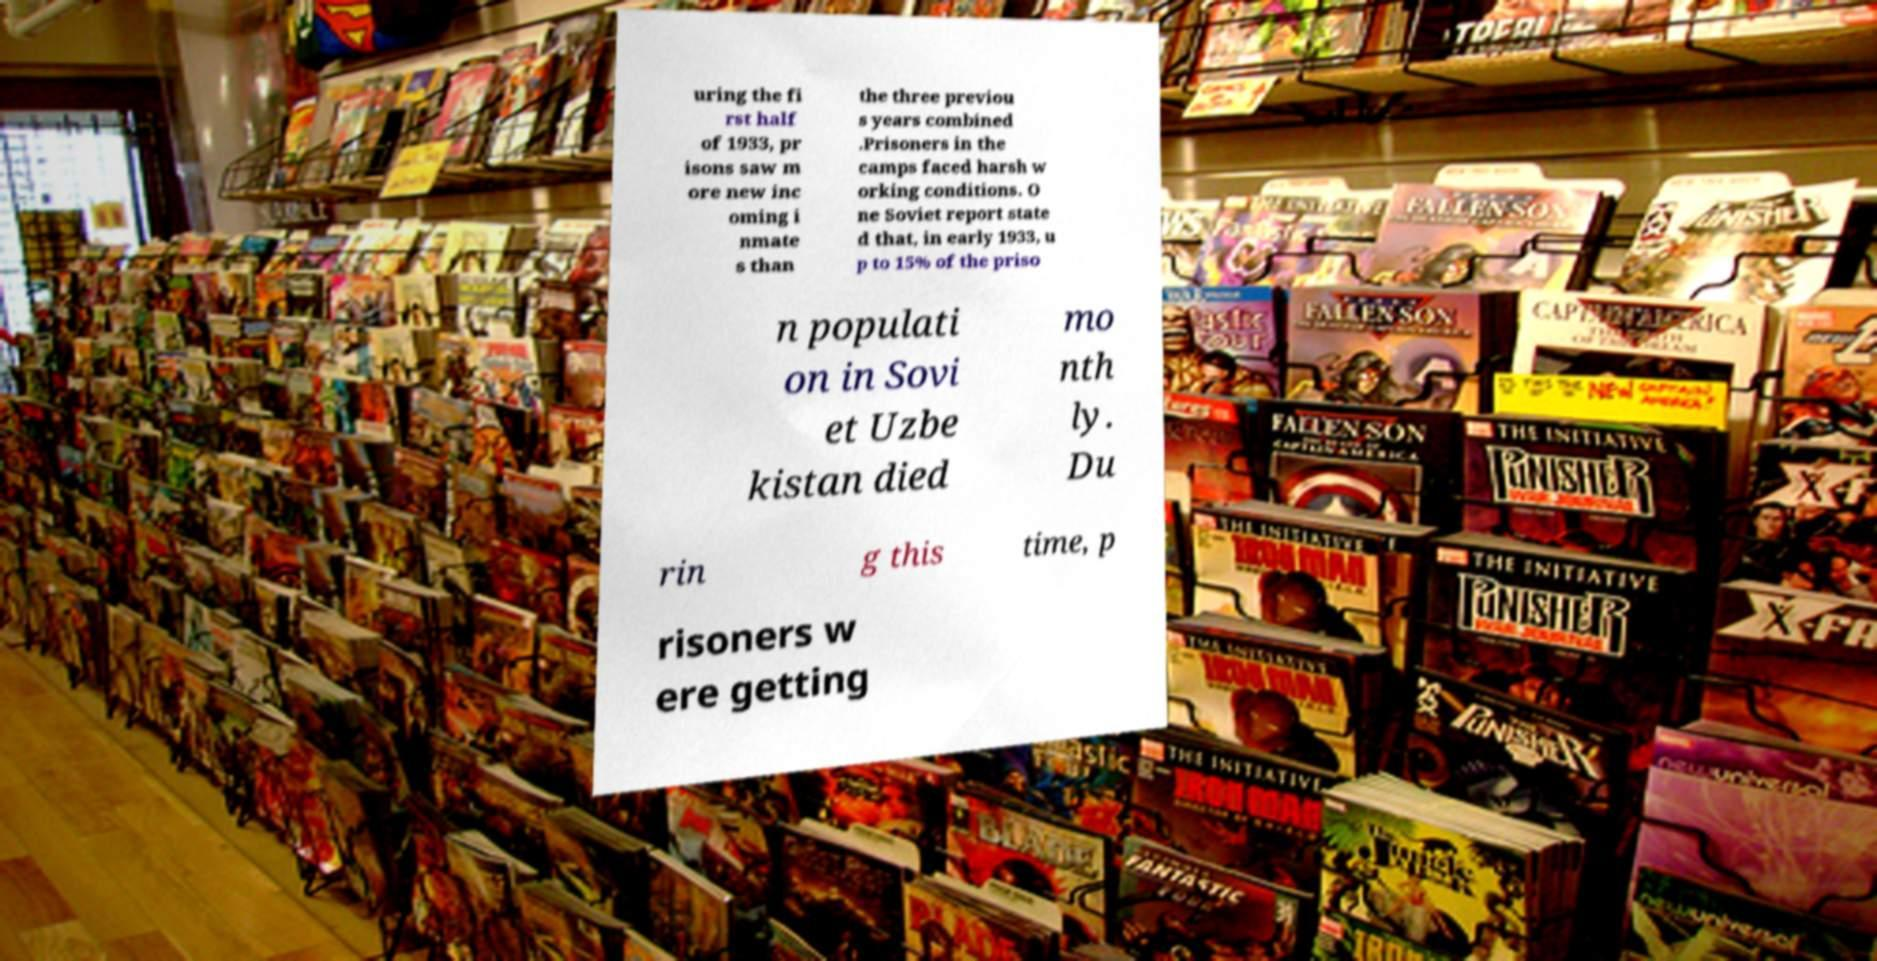Please read and relay the text visible in this image. What does it say? uring the fi rst half of 1933, pr isons saw m ore new inc oming i nmate s than the three previou s years combined .Prisoners in the camps faced harsh w orking conditions. O ne Soviet report state d that, in early 1933, u p to 15% of the priso n populati on in Sovi et Uzbe kistan died mo nth ly. Du rin g this time, p risoners w ere getting 